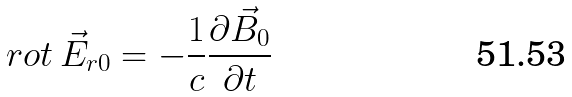<formula> <loc_0><loc_0><loc_500><loc_500>r o t \, \vec { E } _ { r 0 } = - \frac { 1 } { c } \frac { \partial \vec { B } _ { 0 } } { \partial t }</formula> 